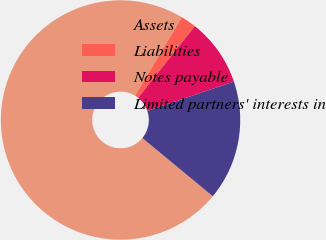Convert chart. <chart><loc_0><loc_0><loc_500><loc_500><pie_chart><fcel>Assets<fcel>Liabilities<fcel>Notes payable<fcel>Limited partners' interests in<nl><fcel>72.57%<fcel>2.1%<fcel>9.14%<fcel>16.19%<nl></chart> 